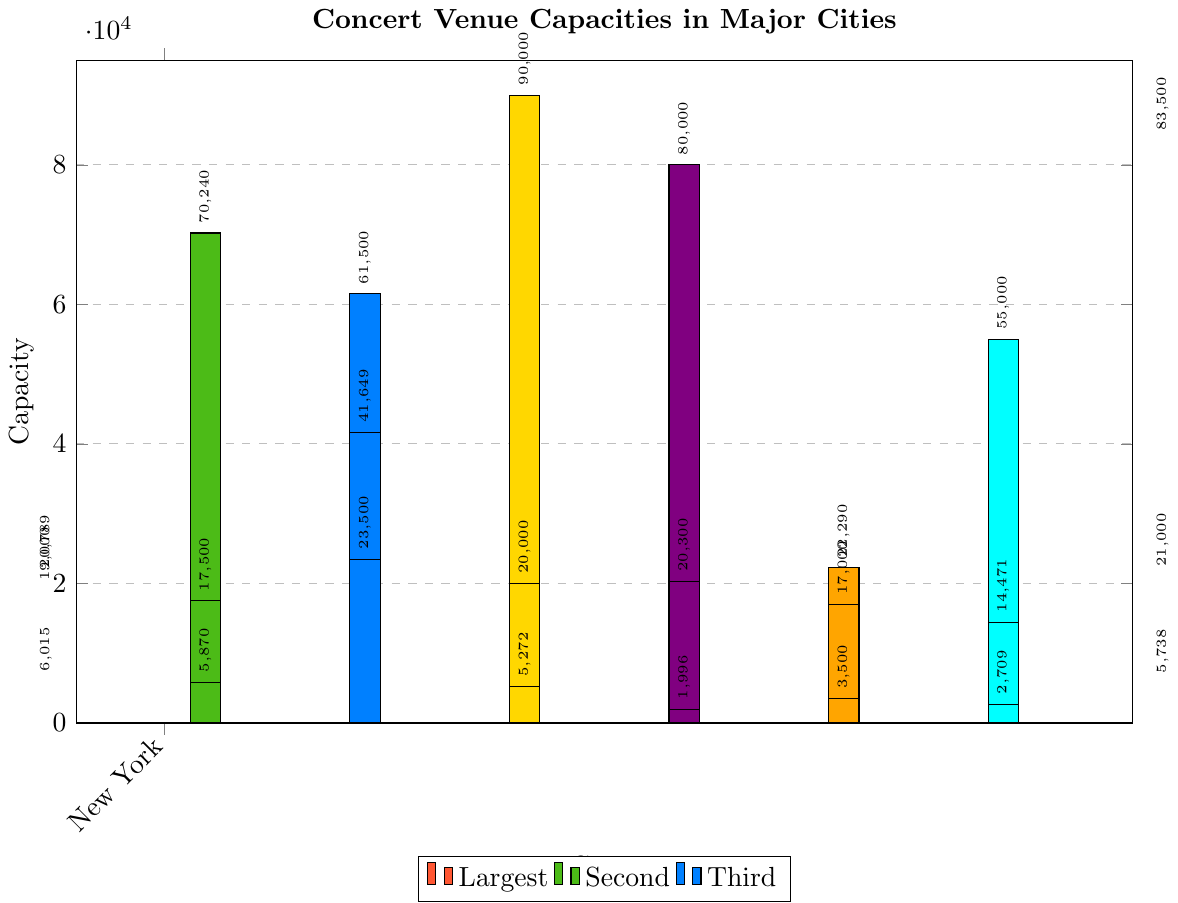Which city has the venue with the highest capacity? Look for the tallest bar in the chart, which represents the highest capacity. The tallest bar belongs to London. Hence, London has the venue with the highest capacity.
Answer: London What is the total capacity for New York's venues? Identify and sum the capacities for Madison Square Garden (20789), Barclays Center (19000), and Radio City Music Hall (6015). The total is 20789 + 19000 + 6015 = 45794.
Answer: 45794 Which cities have at least one venue with a capacity under 5000? Find cities with at least one bar below the 5000 mark. New York (Radio City Music Hall: 6015), Los Angeles (The Greek Theatre: 5870), Berlin (Tempodrom: 3500), Paris (Olympia: 1996), and Tokyo (Zepp Tokyo: 2709) meet this criteria.
Answer: New York, Los Angeles, Berlin, Paris, Tokyo Is the average capacity for venues in London higher than in Paris? Calculate the average capacity for both cities. London: (20000 + 90000 + 5272) / 3 = 38424. Paris: (20300 + 80000 + 1996) / 3 = 34198. When compared, 38424 (London) is higher than 34198 (Paris).
Answer: Yes What's the difference in capacity between the largest and smallest venue in Los Angeles? Find the capacity of the largest venue (SoFi Stadium: 70240) and the smallest venue (The Greek Theatre: 5870). Subtract to find the difference: 70240 - 5870 = 64370.
Answer: 64370 Which city's third-largest venue has the lowest capacity? Identify the third-largest venues by capacity in each city: New York (Radio City Music Hall: 6015), Los Angeles (The Greek Theatre: 5870), Chicago (Wrigley Field: 41649), London (Royal Albert Hall: 5272), Paris (Olympia: 1996), Berlin (Tempodrom: 3500), Tokyo (Zepp Tokyo: 2709), and Sydney (Sydney Opera House: 5738). Paris' Olympia has the lowest capacity at 1996.
Answer: Paris How many venues in Tokyo have a capacity greater than 10000? Identify the venues in Tokyo and check their capacities: Tokyo Dome (55000), Nippon Budokan (14471), and Zepp Tokyo (2709). Both Tokyo Dome and Nippon Budokan have capacities greater than 10000.
Answer: 2 Which venues in Sydney have a smaller capacity than the largest venue in New York? The largest venue in New York is Madison Square Garden (20789). Check Sydney's venues: ANZ Stadium (83500), Qudos Bank Arena (21000), and Sydney Opera House (5738). Only Sydney Opera House has a smaller capacity than Madison Square Garden.
Answer: Sydney Opera House 